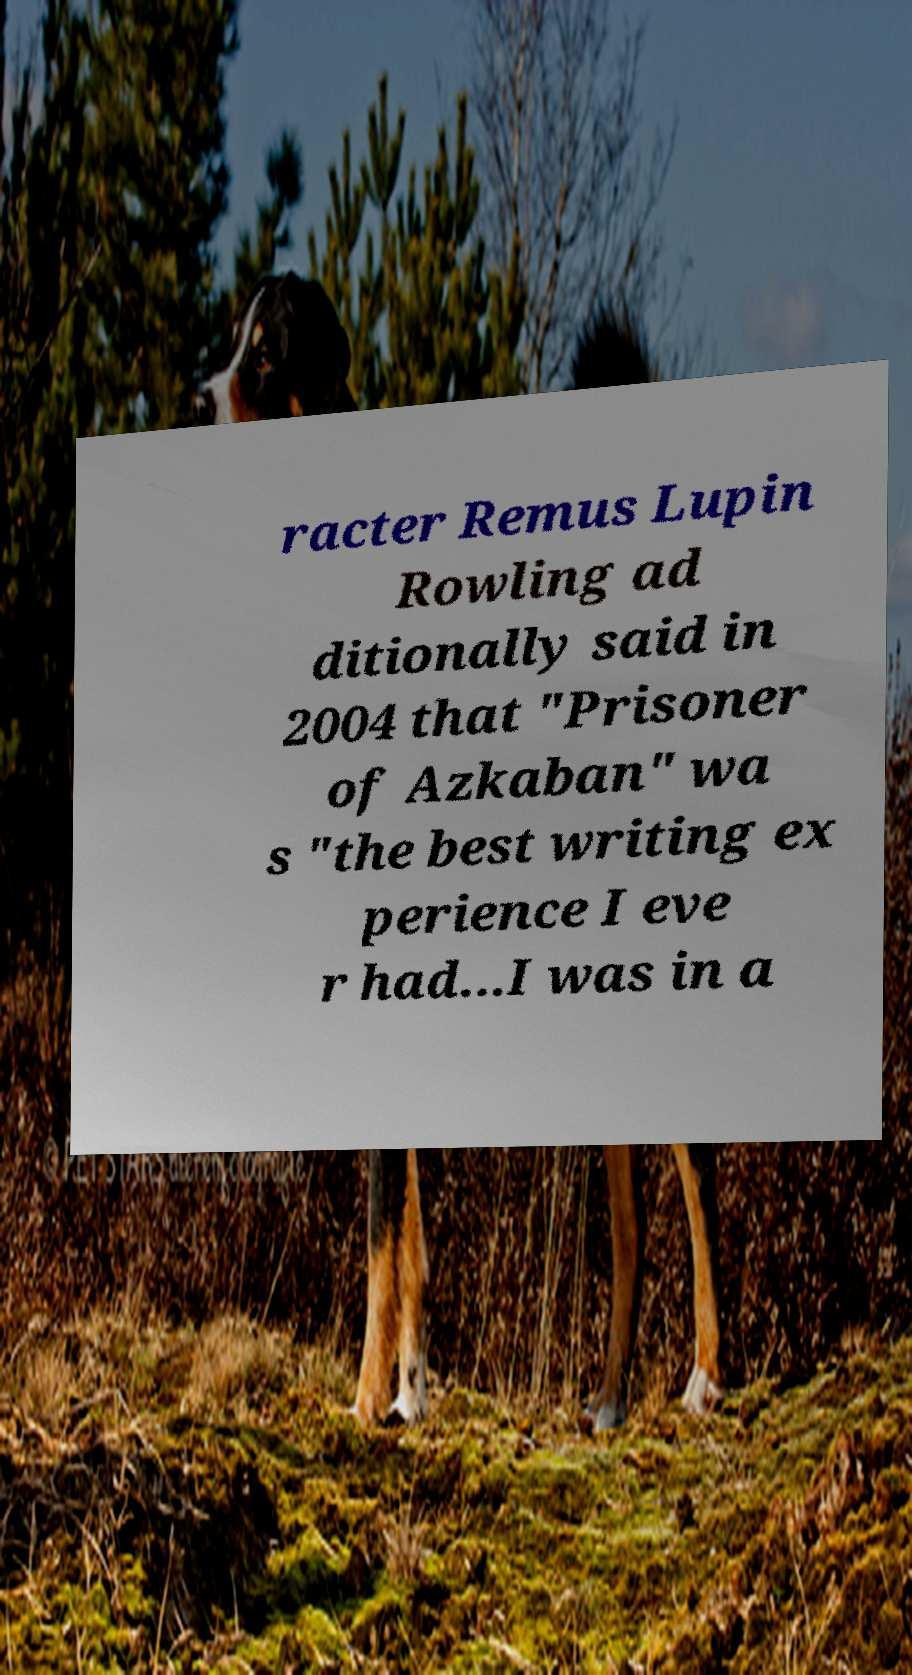I need the written content from this picture converted into text. Can you do that? racter Remus Lupin Rowling ad ditionally said in 2004 that "Prisoner of Azkaban" wa s "the best writing ex perience I eve r had...I was in a 